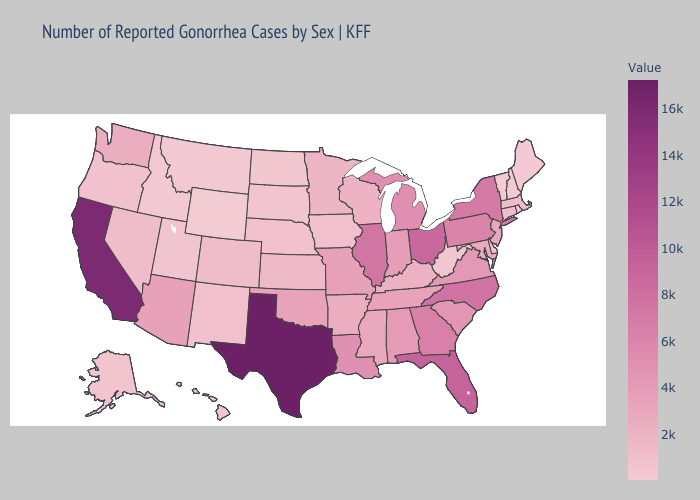Does Virginia have a lower value than Maine?
Write a very short answer. No. Which states have the lowest value in the USA?
Be succinct. Vermont. Among the states that border Indiana , which have the lowest value?
Concise answer only. Kentucky. Which states have the highest value in the USA?
Be succinct. Texas. Does North Dakota have the lowest value in the MidWest?
Keep it brief. Yes. Among the states that border Washington , which have the lowest value?
Keep it brief. Idaho. Which states have the lowest value in the South?
Short answer required. West Virginia. Is the legend a continuous bar?
Quick response, please. Yes. 